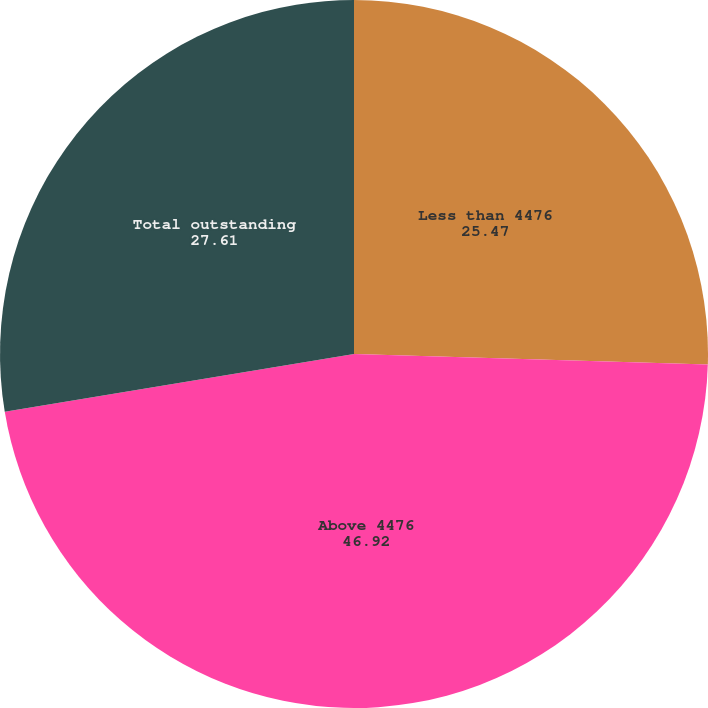Convert chart to OTSL. <chart><loc_0><loc_0><loc_500><loc_500><pie_chart><fcel>Less than 4476<fcel>Above 4476<fcel>Total outstanding<nl><fcel>25.47%<fcel>46.92%<fcel>27.61%<nl></chart> 